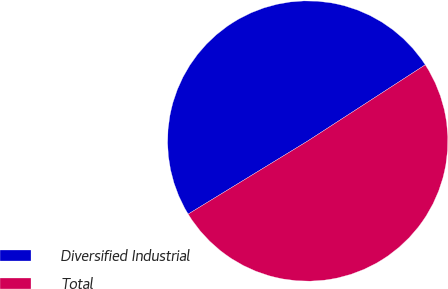<chart> <loc_0><loc_0><loc_500><loc_500><pie_chart><fcel>Diversified Industrial<fcel>Total<nl><fcel>49.58%<fcel>50.42%<nl></chart> 